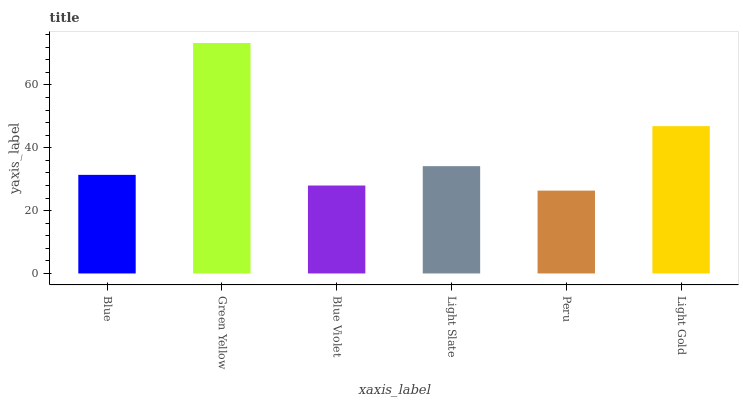Is Peru the minimum?
Answer yes or no. Yes. Is Green Yellow the maximum?
Answer yes or no. Yes. Is Blue Violet the minimum?
Answer yes or no. No. Is Blue Violet the maximum?
Answer yes or no. No. Is Green Yellow greater than Blue Violet?
Answer yes or no. Yes. Is Blue Violet less than Green Yellow?
Answer yes or no. Yes. Is Blue Violet greater than Green Yellow?
Answer yes or no. No. Is Green Yellow less than Blue Violet?
Answer yes or no. No. Is Light Slate the high median?
Answer yes or no. Yes. Is Blue the low median?
Answer yes or no. Yes. Is Green Yellow the high median?
Answer yes or no. No. Is Peru the low median?
Answer yes or no. No. 